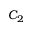<formula> <loc_0><loc_0><loc_500><loc_500>C _ { 2 }</formula> 